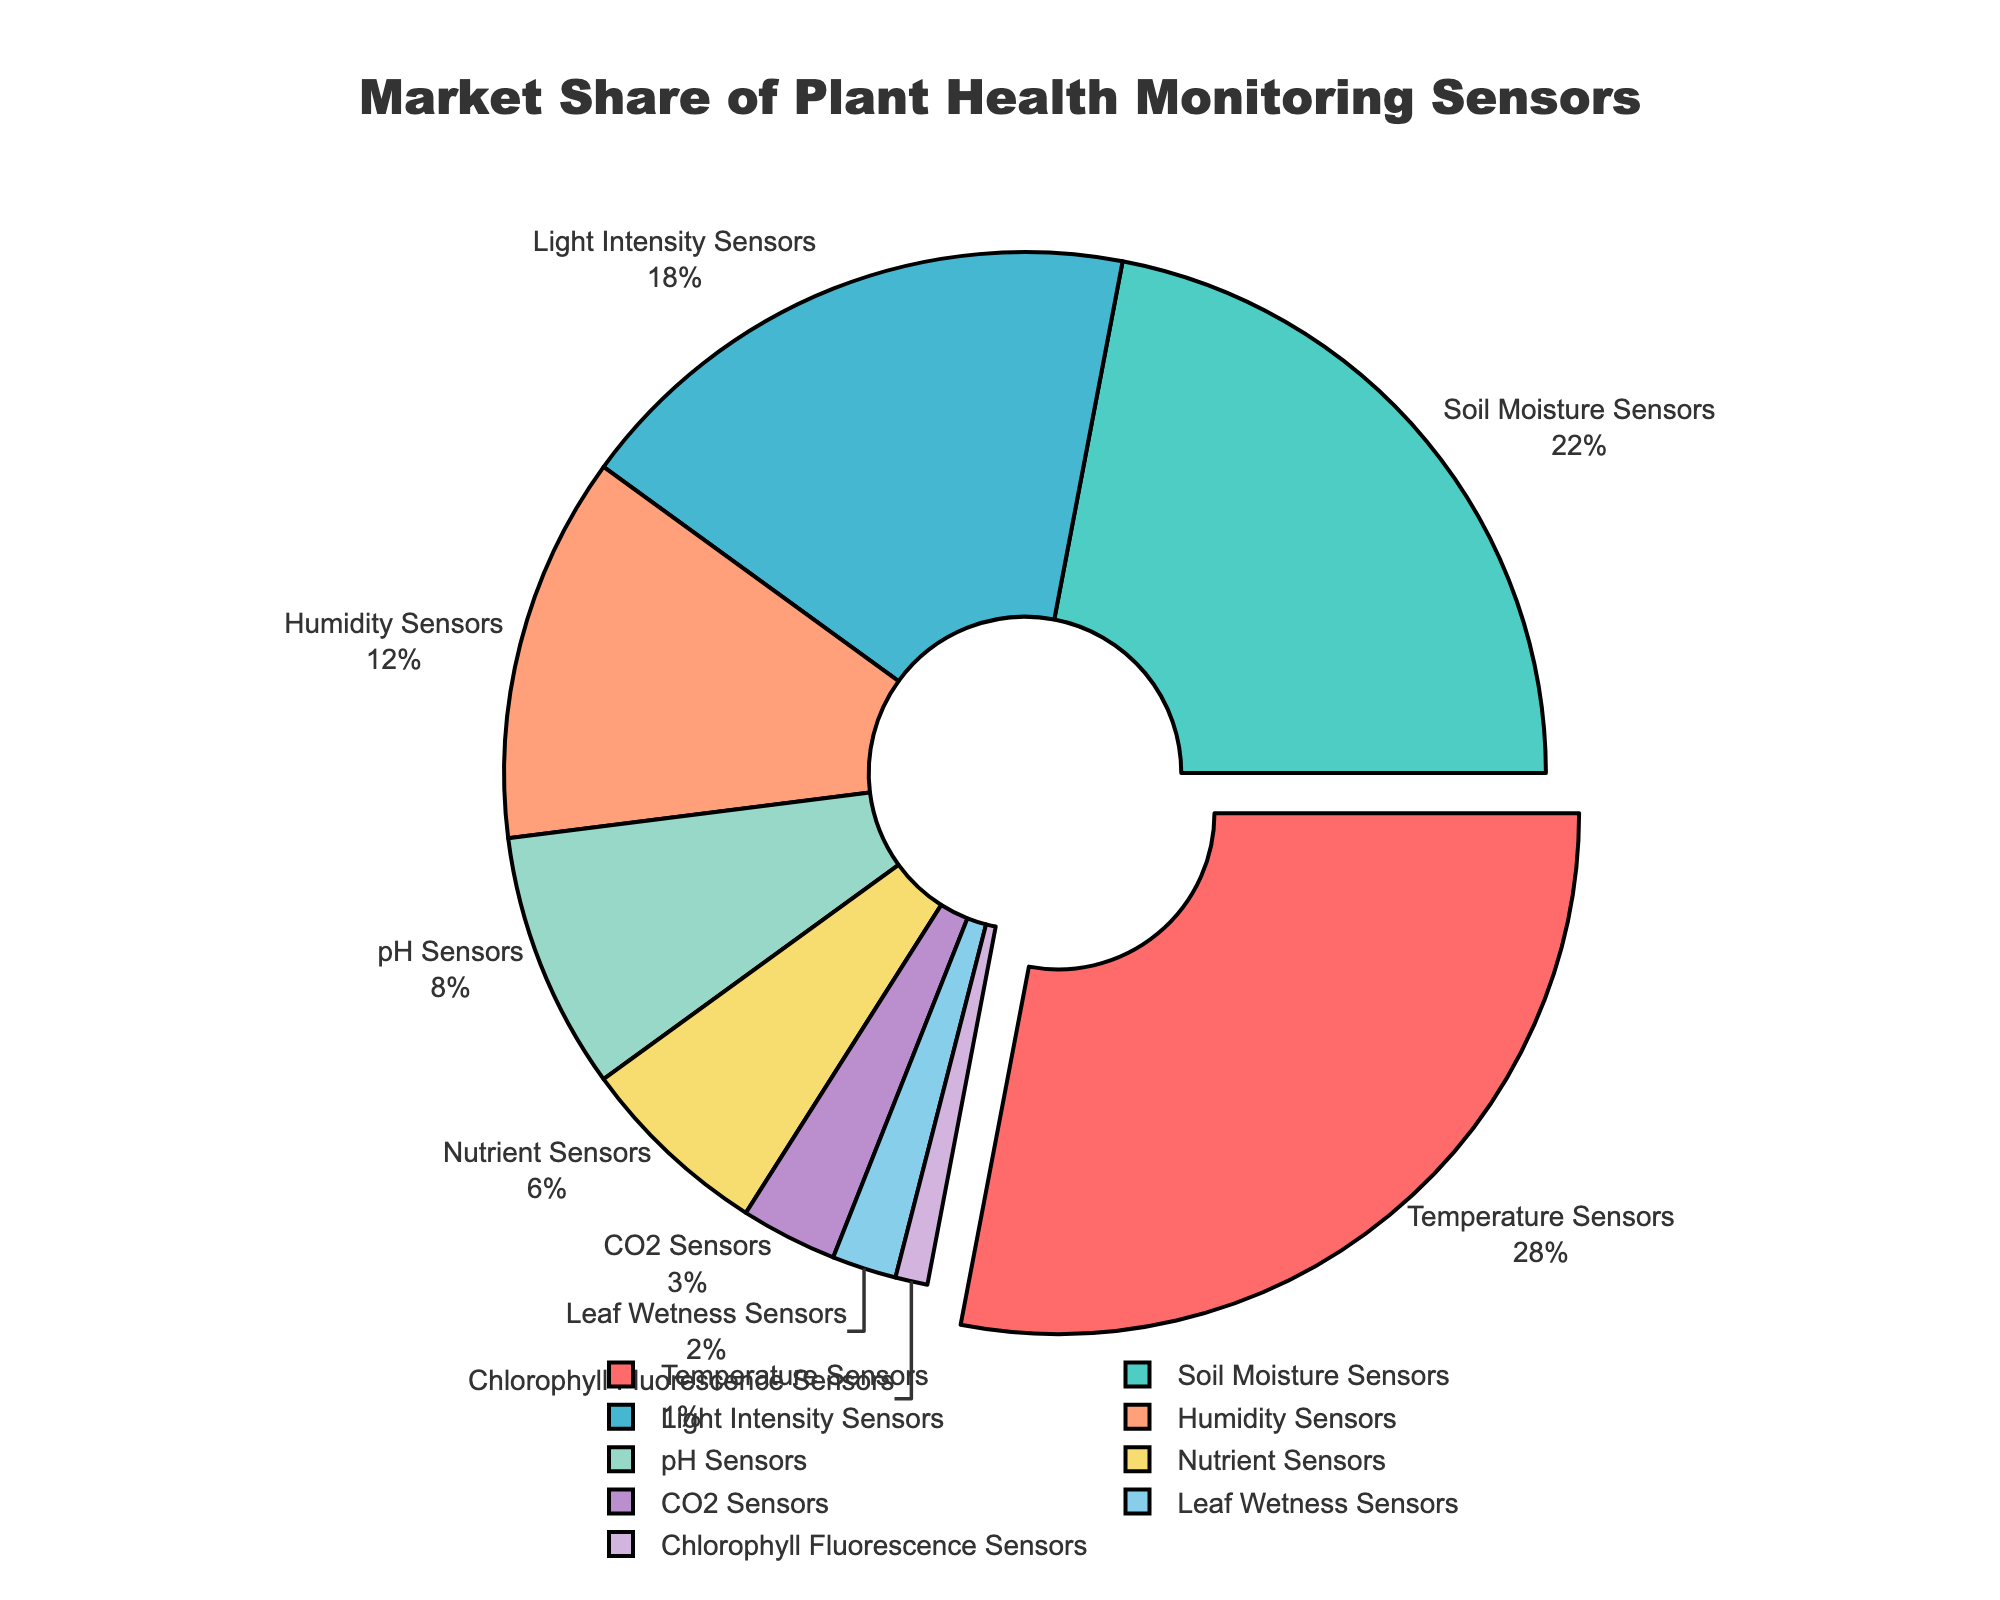Which sensor type has the highest market share? The pie chart shows that the Temperature Sensors segment has the largest portion pulled out, indicating it has the highest market share.
Answer: Temperature Sensors What is the combined market share of Soil Moisture Sensors and Light Intensity Sensors? Soil Moisture Sensors have a 22% market share and Light Intensity Sensors have 18%. Adding these together gives 22% + 18% = 40%.
Answer: 40% What percentage of the market is captured by Humidity Sensors and pH Sensors together? Humidity Sensors hold 12% and pH Sensors hold 8% of the market. The combined market share is 12% + 8% = 20%.
Answer: 20% Which sensor type has the least market share? The pie chart shows that Chlorophyll Fluorescence Sensors have the smallest segment, indicating the lowest market share.
Answer: Chlorophyll Fluorescence Sensors Compare the market share of Nutrient Sensors to CO2 Sensors. Which one is higher and by how much? Nutrient Sensors have a market share of 6% while CO2 Sensors hold 3%. The difference is 6% - 3% = 3%. Nutrient Sensors have a higher market share by 3%.
Answer: Nutrient Sensors by 3% By how much does the market share of Light Intensity Sensors exceed that of CO2 Sensors? Light Intensity Sensors have an 18% market share, and CO2 Sensors have a 3% share. The difference is 18% - 3% = 15%.
Answer: 15% What portion of the market is taken up by sensors related to light (Light Intensity Sensors and Chlorophyll Fluorescence Sensors)? Light Intensity Sensors have an 18% share, and Chlorophyll Fluorescence Sensors have 1%. Adding these together gives 18% + 1% = 19%.
Answer: 19% How many sensor types have a market share of less than 10%? The sensor types with less than 10% share are pH Sensors, Nutrient Sensors, CO2 Sensors, Leaf Wetness Sensors, and Chlorophyll Fluorescence Sensors. There are 5 such types.
Answer: 5 